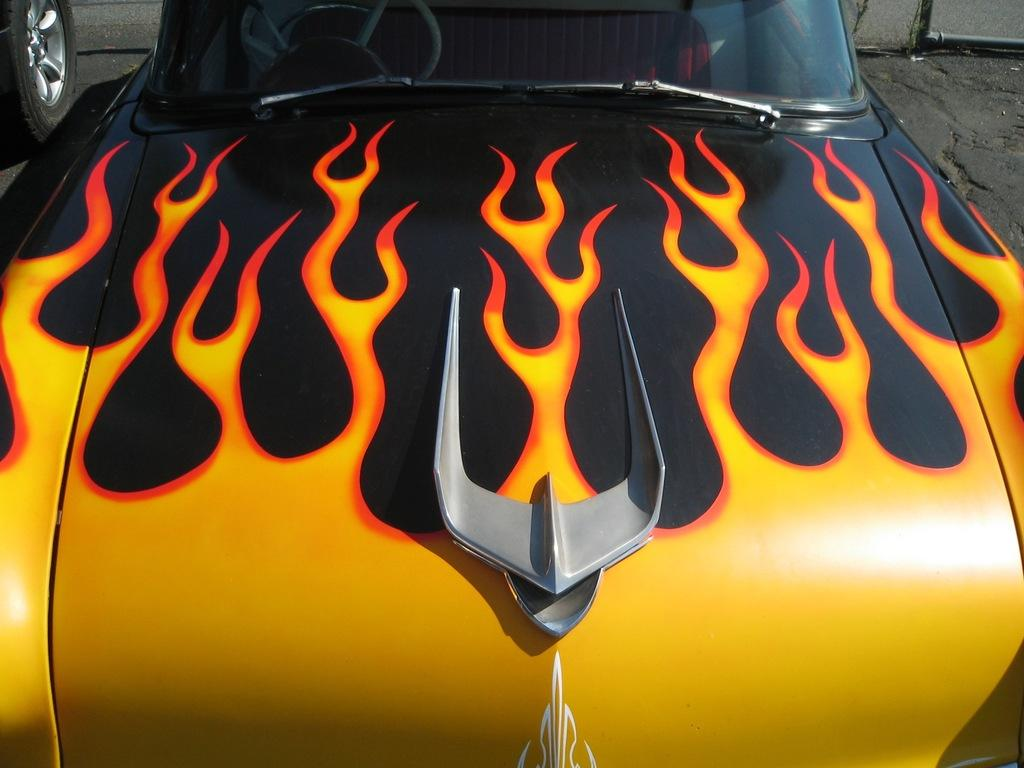What is the main subject of the image? There is a vehicle in the image. Can you describe any specific part of the vehicle? There is a tire of a vehicle in the image. What type of faucet can be seen in the image? There is no faucet present in the image. 